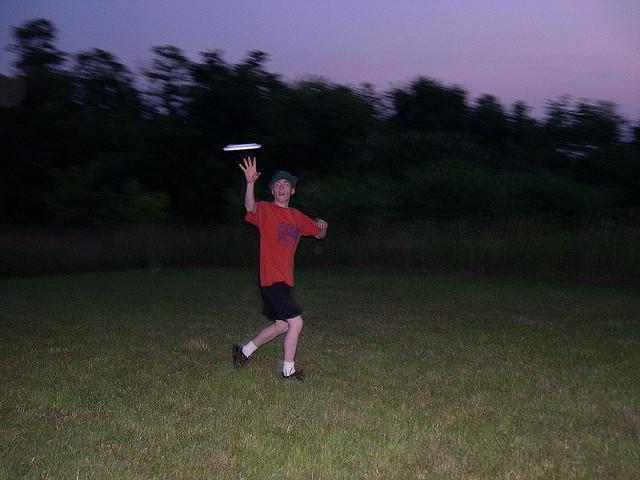How many girls are in this picture?
Give a very brief answer. 0. How many chairs are standing with the table?
Give a very brief answer. 0. 